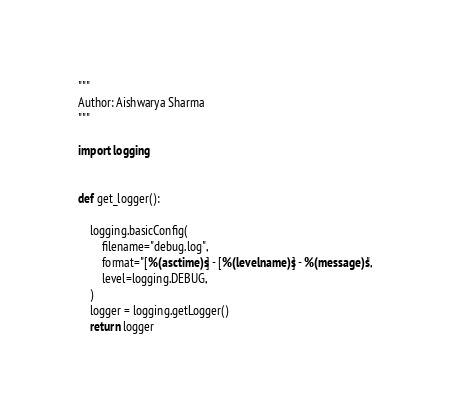<code> <loc_0><loc_0><loc_500><loc_500><_Python_>"""
Author: Aishwarya Sharma
"""

import logging


def get_logger():

    logging.basicConfig(
        filename="debug.log",
        format="[%(asctime)s] - [%(levelname)s] - %(message)s",
        level=logging.DEBUG,
    )
    logger = logging.getLogger()
    return logger
</code> 